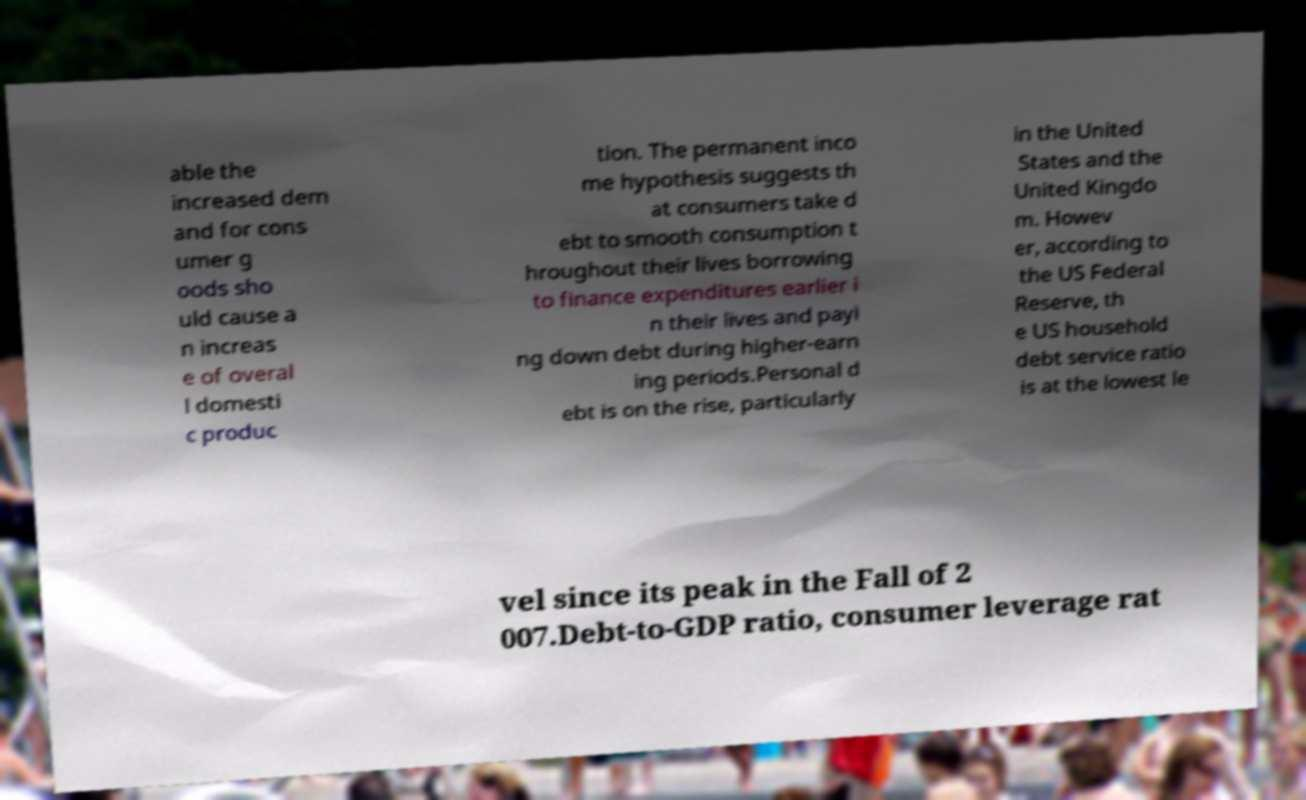For documentation purposes, I need the text within this image transcribed. Could you provide that? able the increased dem and for cons umer g oods sho uld cause a n increas e of overal l domesti c produc tion. The permanent inco me hypothesis suggests th at consumers take d ebt to smooth consumption t hroughout their lives borrowing to finance expenditures earlier i n their lives and payi ng down debt during higher-earn ing periods.Personal d ebt is on the rise, particularly in the United States and the United Kingdo m. Howev er, according to the US Federal Reserve, th e US household debt service ratio is at the lowest le vel since its peak in the Fall of 2 007.Debt-to-GDP ratio, consumer leverage rat 